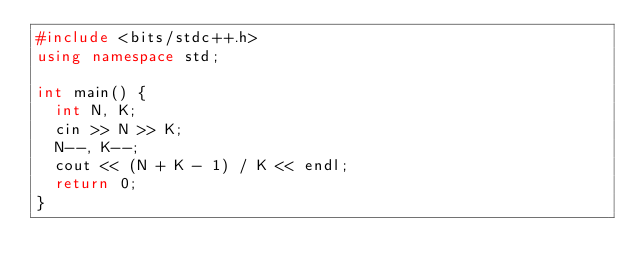Convert code to text. <code><loc_0><loc_0><loc_500><loc_500><_C++_>#include <bits/stdc++.h>
using namespace std;

int main() {
  int N, K;
  cin >> N >> K;
  N--, K--;
  cout << (N + K - 1) / K << endl;
  return 0;
}
</code> 